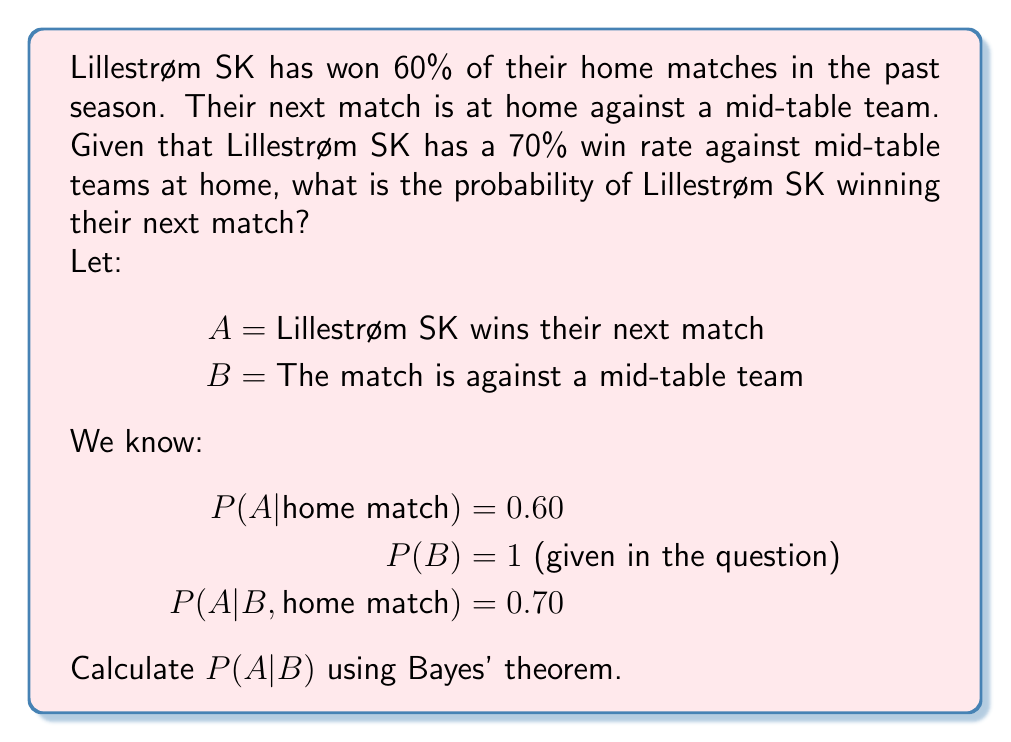Solve this math problem. To solve this problem, we'll use Bayes' theorem:

$$P(A|B) = \frac{P(B|A) \cdot P(A)}{P(B)}$$

However, we're given conditional probabilities based on home matches, so we'll modify our approach:

1) We know that P(A|B, home match) = 0.70. This is already our answer, as we're given that the next match is at home against a mid-table team.

2) We don't need to use the general win rate for home matches (60%) in this calculation, as we have more specific information about Lillestrøm SK's performance against mid-table teams at home.

3) The probability of the match being against a mid-table team, P(B), is 1, as it's given in the question.

Therefore, the probability of Lillestrøm SK winning their next match, given that it's a home match against a mid-table team, is simply:

$$P(A|B, \text{home match}) = 0.70 = 70\%$$

This direct approach is valid because we have specific information about the exact scenario we're interested in, eliminating the need for a more complex Bayesian calculation.
Answer: 70% 